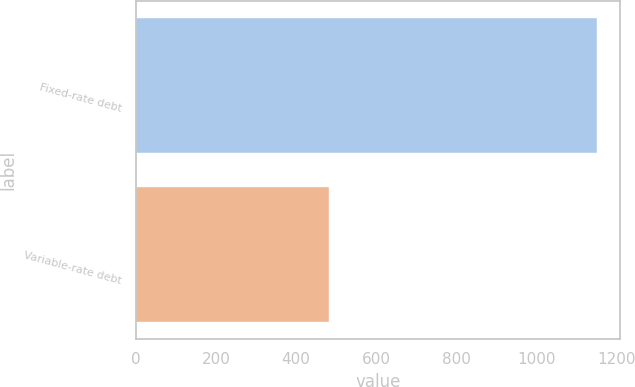Convert chart to OTSL. <chart><loc_0><loc_0><loc_500><loc_500><bar_chart><fcel>Fixed-rate debt<fcel>Variable-rate debt<nl><fcel>1151<fcel>483<nl></chart> 